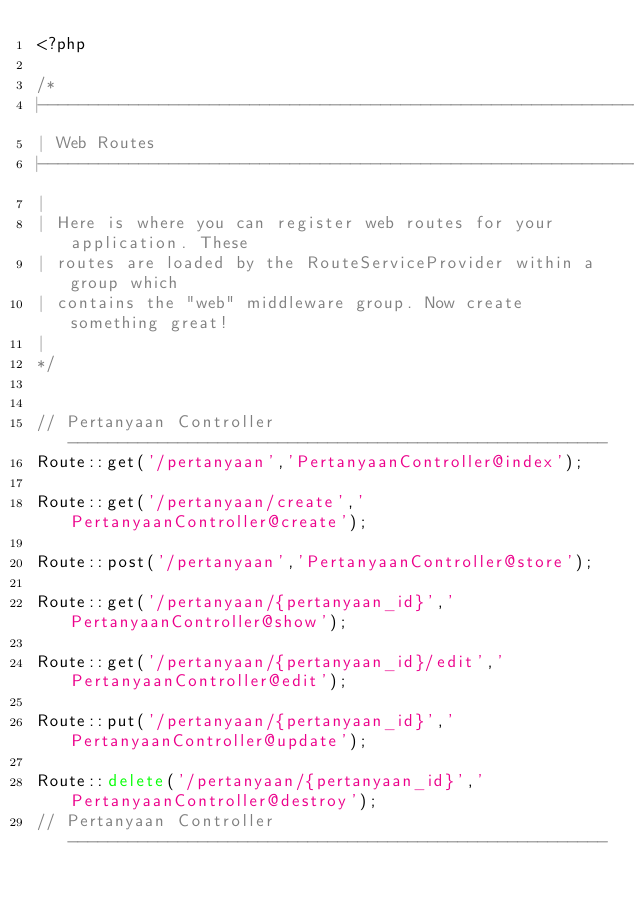<code> <loc_0><loc_0><loc_500><loc_500><_PHP_><?php

/*
|--------------------------------------------------------------------------
| Web Routes
|--------------------------------------------------------------------------
|
| Here is where you can register web routes for your application. These
| routes are loaded by the RouteServiceProvider within a group which
| contains the "web" middleware group. Now create something great!
|
*/


// Pertanyaan Controller  ------------------------------------------------------
Route::get('/pertanyaan','PertanyaanController@index');

Route::get('/pertanyaan/create','PertanyaanController@create');

Route::post('/pertanyaan','PertanyaanController@store');

Route::get('/pertanyaan/{pertanyaan_id}','PertanyaanController@show');

Route::get('/pertanyaan/{pertanyaan_id}/edit','PertanyaanController@edit');

Route::put('/pertanyaan/{pertanyaan_id}','PertanyaanController@update');

Route::delete('/pertanyaan/{pertanyaan_id}','PertanyaanController@destroy');
// Pertanyaan Controller  ------------------------------------------------------




</code> 